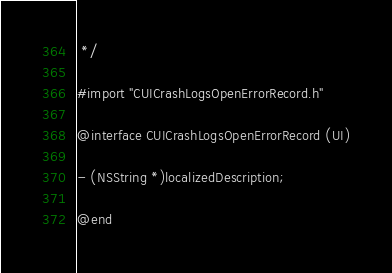Convert code to text. <code><loc_0><loc_0><loc_500><loc_500><_C_> */

#import "CUICrashLogsOpenErrorRecord.h"

@interface CUICrashLogsOpenErrorRecord (UI)

- (NSString *)localizedDescription;

@end
</code> 